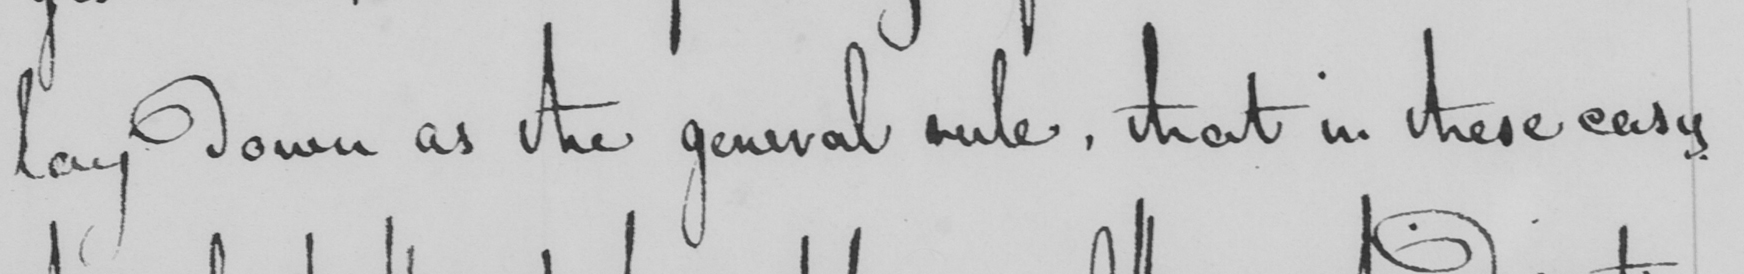What does this handwritten line say? lay down as the general rule, that in these easy 